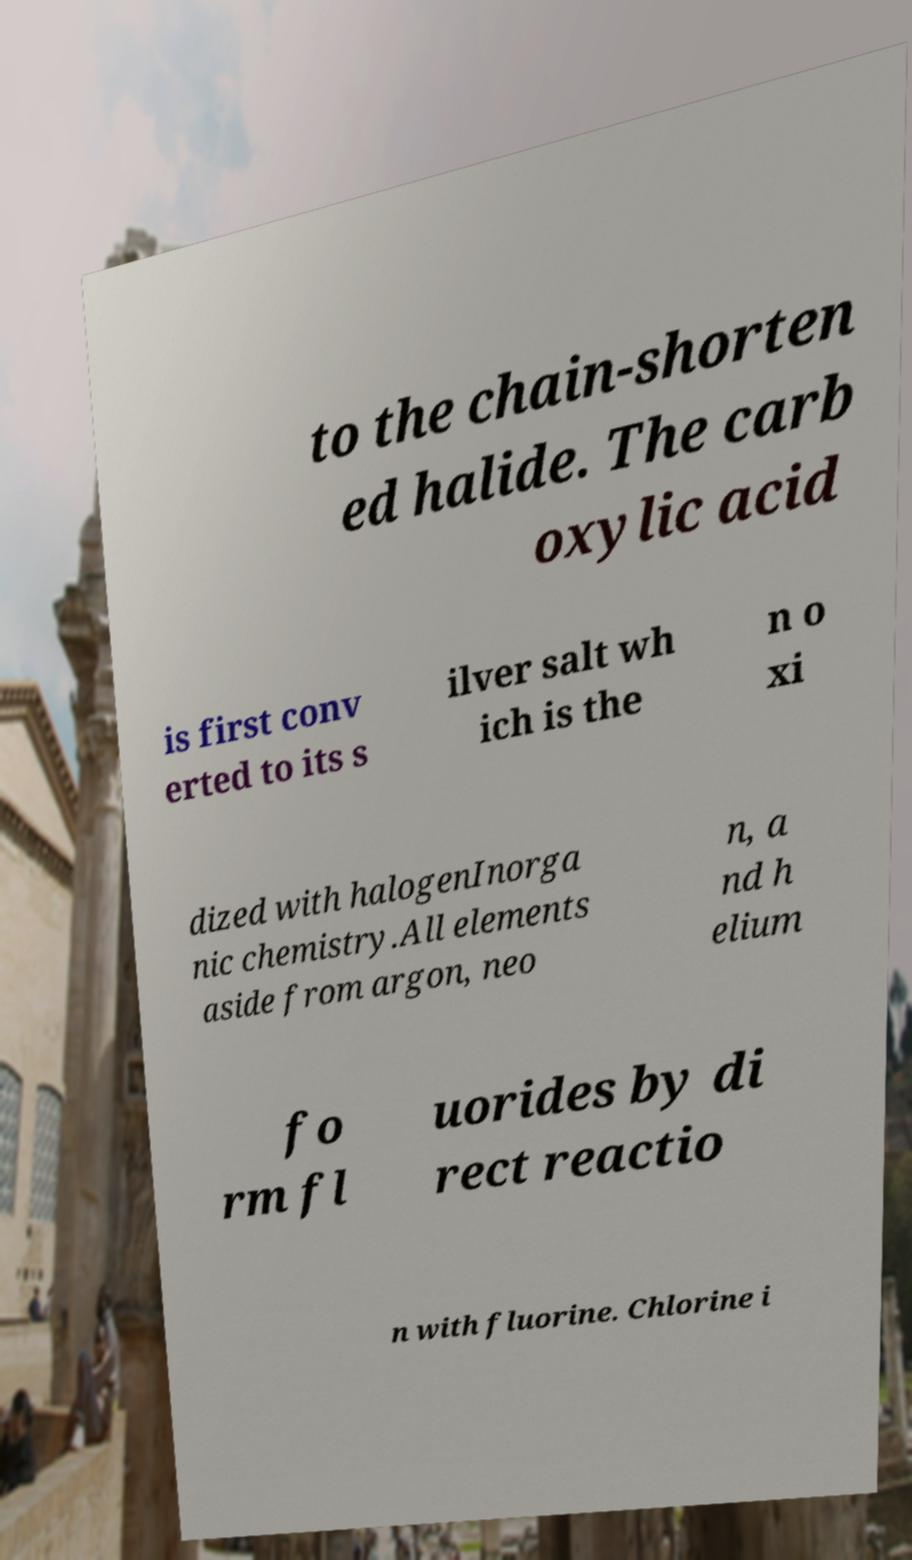Please read and relay the text visible in this image. What does it say? to the chain-shorten ed halide. The carb oxylic acid is first conv erted to its s ilver salt wh ich is the n o xi dized with halogenInorga nic chemistry.All elements aside from argon, neo n, a nd h elium fo rm fl uorides by di rect reactio n with fluorine. Chlorine i 